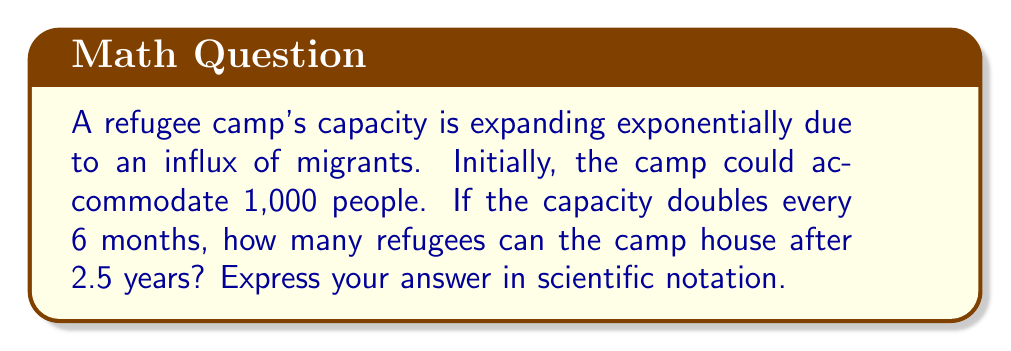Can you solve this math problem? Let's approach this step-by-step:

1) First, we need to identify the components of our exponential function:
   - Initial value (a): 1,000
   - Growth rate (r): doubles every 6 months, so r = 2
   - Time (t): 2.5 years

2) The exponential function is of the form: $$ f(t) = a \cdot r^t $$

3) However, we need to adjust our time unit. The growth rate is per 6 months, but our time is in years. In 2.5 years, there are 5 six-month periods. So our adjusted function is:

   $$ f(t) = 1000 \cdot 2^5 $$

4) Now let's calculate:
   $$ f(t) = 1000 \cdot 2^5 $$
   $$ = 1000 \cdot 32 $$
   $$ = 32,000 $$

5) To express this in scientific notation, we move the decimal point 4 places to the left:
   $$ 32,000 = 3.2 \times 10^4 $$

Thus, after 2.5 years, the camp can house $3.2 \times 10^4$ refugees.
Answer: $3.2 \times 10^4$ 